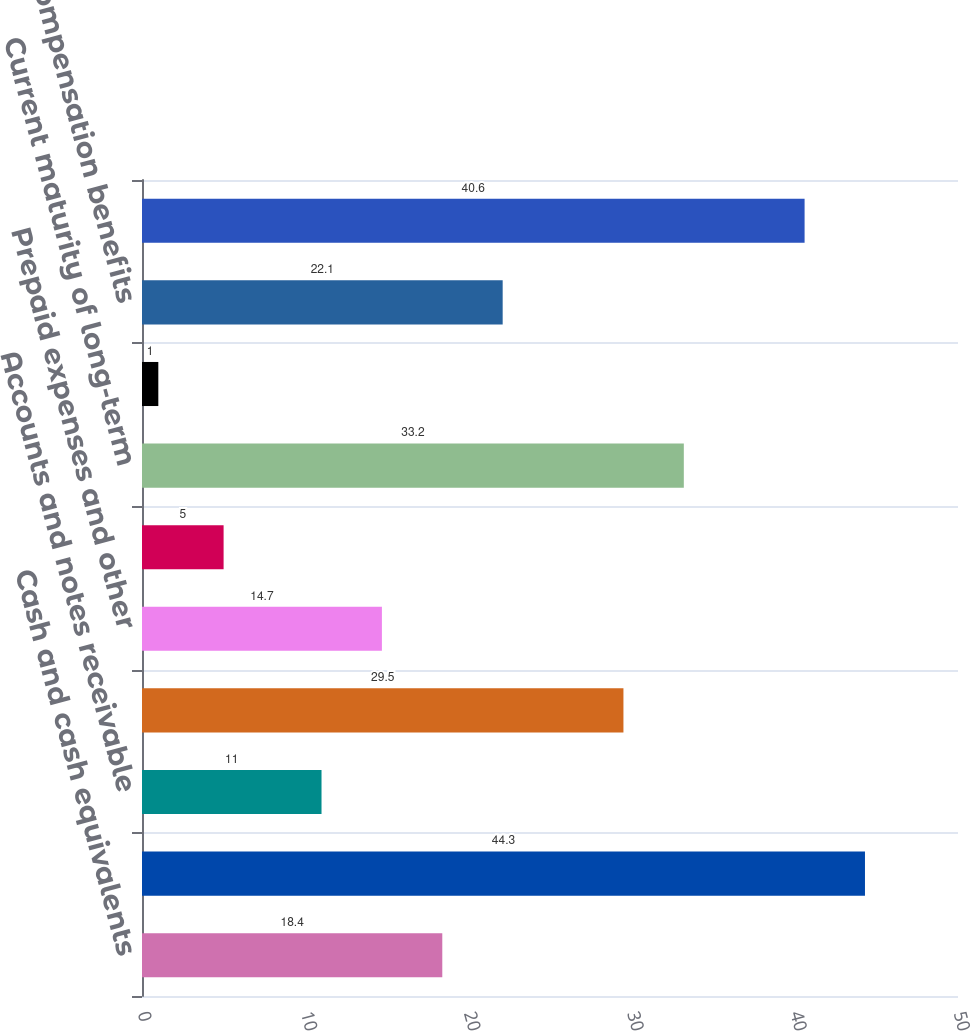Convert chart to OTSL. <chart><loc_0><loc_0><loc_500><loc_500><bar_chart><fcel>Cash and cash equivalents<fcel>Marketable securities<fcel>Accounts and notes receivable<fcel>Inventories<fcel>Prepaid expenses and other<fcel>Current assets<fcel>Current maturity of long-term<fcel>Current portion of accrued<fcel>Accrued compensation benefits<fcel>Taxes payable (including taxes<nl><fcel>18.4<fcel>44.3<fcel>11<fcel>29.5<fcel>14.7<fcel>5<fcel>33.2<fcel>1<fcel>22.1<fcel>40.6<nl></chart> 